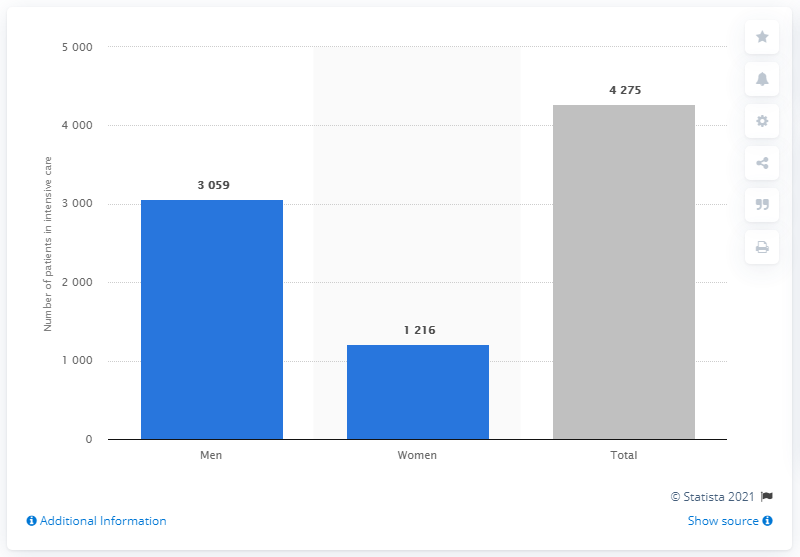Can you describe the key data points reflected in this bar chart related to COVID-19 patients in Swedish intensive care units? Certainly, the bar chart indicates that there are 3,059 male patients and 1,216 female patients in intensive care due to COVID-19 in Sweden. The total number of such patients is 4,275. 